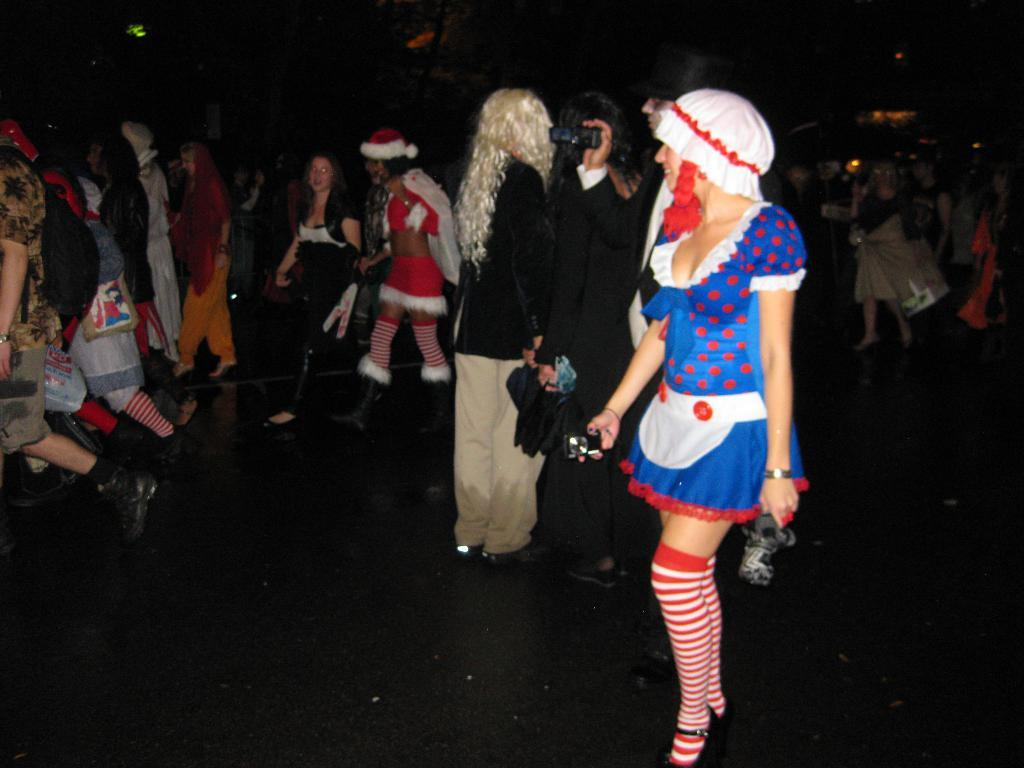What is happening in the image? There is a group of people in the image. What are the people doing in the image? The people are walking on the floor. Can you describe the appearance of some of the people in the image? Some of the people are wearing drama costumes. What type of suit is the creature wearing in the image? There is no creature present in the image, and therefore no suit can be observed. 